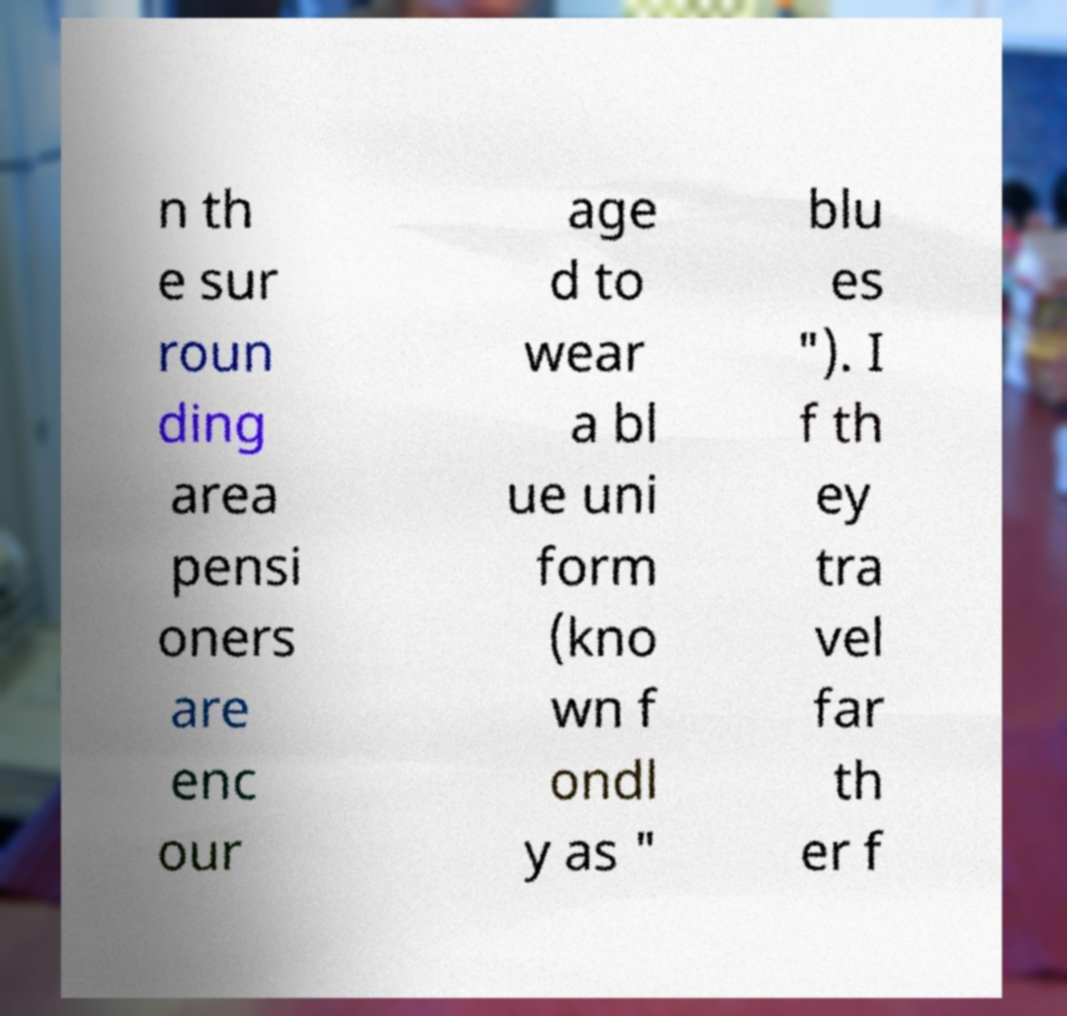Please identify and transcribe the text found in this image. n th e sur roun ding area pensi oners are enc our age d to wear a bl ue uni form (kno wn f ondl y as " blu es "). I f th ey tra vel far th er f 